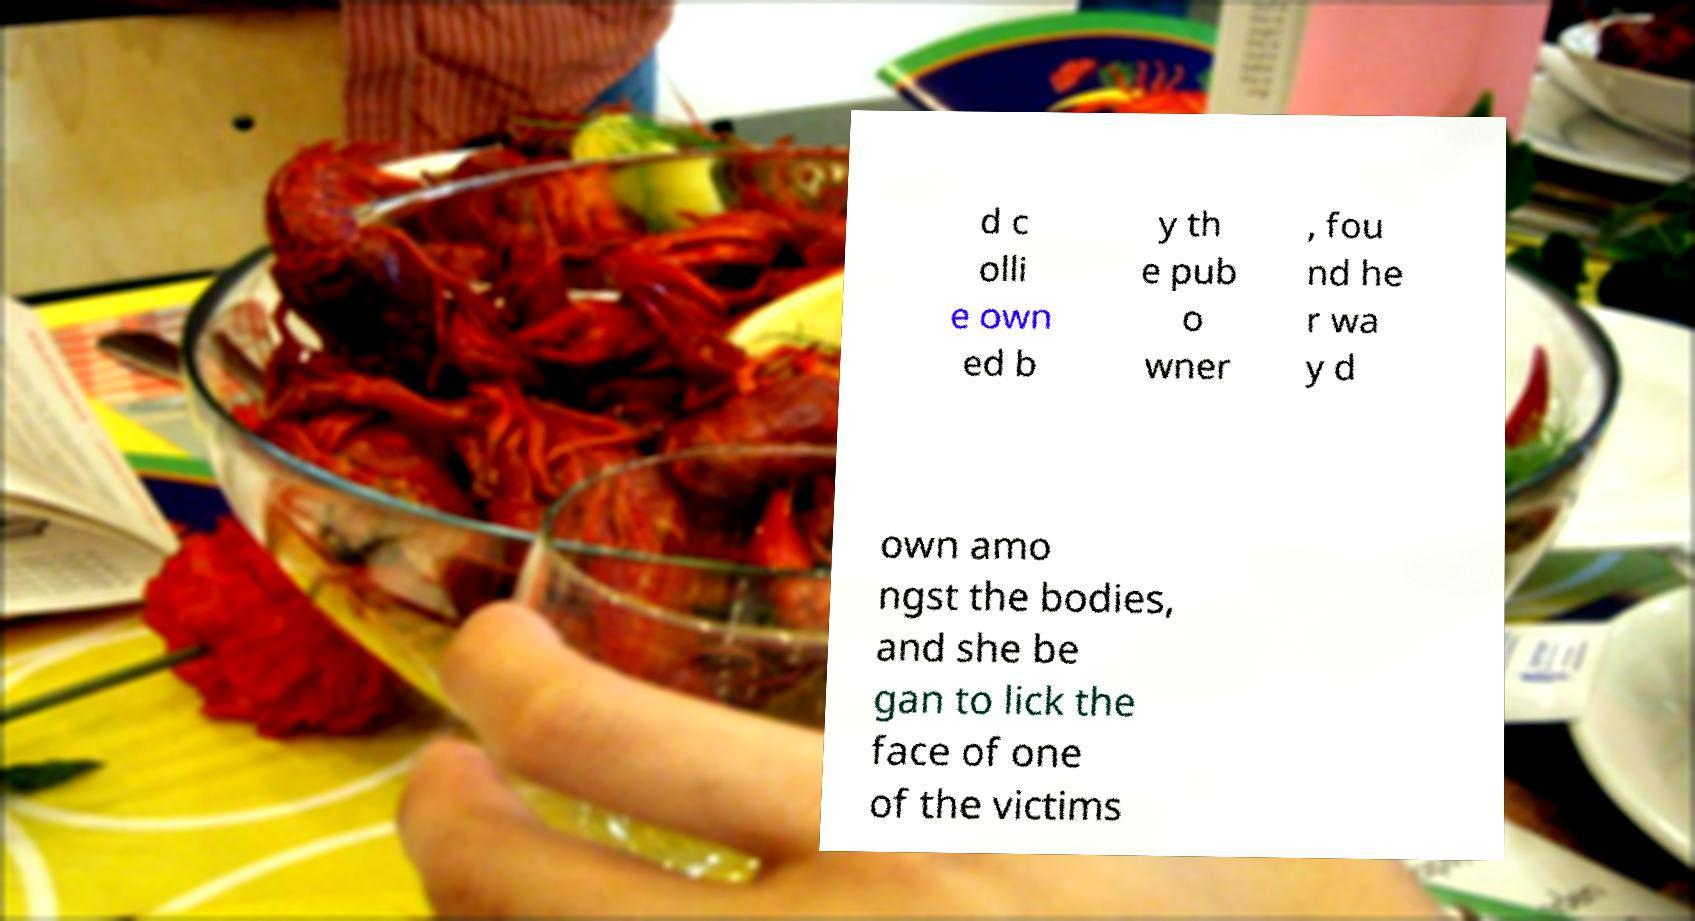There's text embedded in this image that I need extracted. Can you transcribe it verbatim? d c olli e own ed b y th e pub o wner , fou nd he r wa y d own amo ngst the bodies, and she be gan to lick the face of one of the victims 